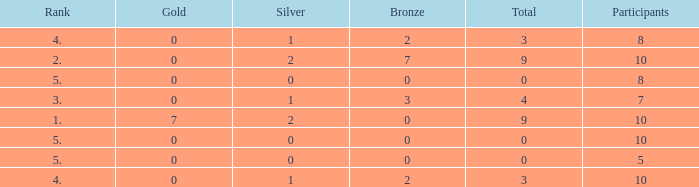What is listed as the highest Gold that also has a Silver that's smaller than 1, and has a Total that's smaller than 0? None. 